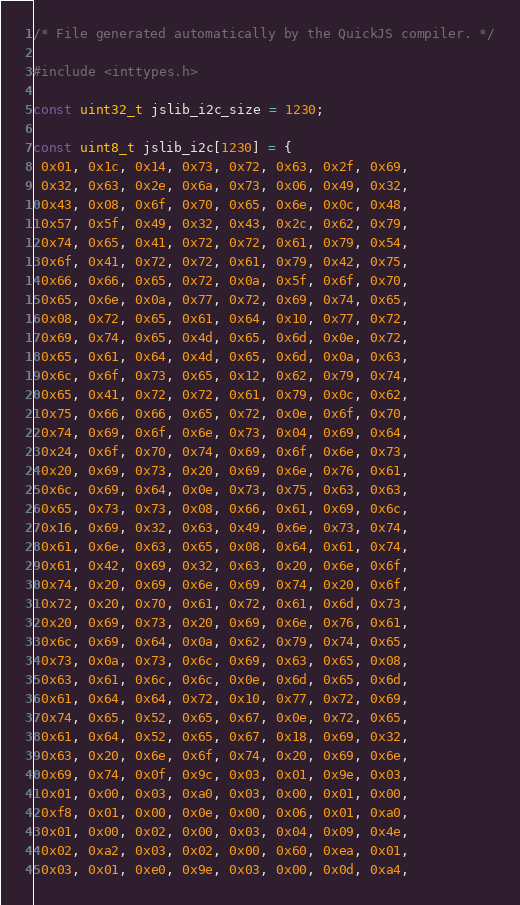<code> <loc_0><loc_0><loc_500><loc_500><_C_>/* File generated automatically by the QuickJS compiler. */

#include <inttypes.h>

const uint32_t jslib_i2c_size = 1230;

const uint8_t jslib_i2c[1230] = {
 0x01, 0x1c, 0x14, 0x73, 0x72, 0x63, 0x2f, 0x69,
 0x32, 0x63, 0x2e, 0x6a, 0x73, 0x06, 0x49, 0x32,
 0x43, 0x08, 0x6f, 0x70, 0x65, 0x6e, 0x0c, 0x48,
 0x57, 0x5f, 0x49, 0x32, 0x43, 0x2c, 0x62, 0x79,
 0x74, 0x65, 0x41, 0x72, 0x72, 0x61, 0x79, 0x54,
 0x6f, 0x41, 0x72, 0x72, 0x61, 0x79, 0x42, 0x75,
 0x66, 0x66, 0x65, 0x72, 0x0a, 0x5f, 0x6f, 0x70,
 0x65, 0x6e, 0x0a, 0x77, 0x72, 0x69, 0x74, 0x65,
 0x08, 0x72, 0x65, 0x61, 0x64, 0x10, 0x77, 0x72,
 0x69, 0x74, 0x65, 0x4d, 0x65, 0x6d, 0x0e, 0x72,
 0x65, 0x61, 0x64, 0x4d, 0x65, 0x6d, 0x0a, 0x63,
 0x6c, 0x6f, 0x73, 0x65, 0x12, 0x62, 0x79, 0x74,
 0x65, 0x41, 0x72, 0x72, 0x61, 0x79, 0x0c, 0x62,
 0x75, 0x66, 0x66, 0x65, 0x72, 0x0e, 0x6f, 0x70,
 0x74, 0x69, 0x6f, 0x6e, 0x73, 0x04, 0x69, 0x64,
 0x24, 0x6f, 0x70, 0x74, 0x69, 0x6f, 0x6e, 0x73,
 0x20, 0x69, 0x73, 0x20, 0x69, 0x6e, 0x76, 0x61,
 0x6c, 0x69, 0x64, 0x0e, 0x73, 0x75, 0x63, 0x63,
 0x65, 0x73, 0x73, 0x08, 0x66, 0x61, 0x69, 0x6c,
 0x16, 0x69, 0x32, 0x63, 0x49, 0x6e, 0x73, 0x74,
 0x61, 0x6e, 0x63, 0x65, 0x08, 0x64, 0x61, 0x74,
 0x61, 0x42, 0x69, 0x32, 0x63, 0x20, 0x6e, 0x6f,
 0x74, 0x20, 0x69, 0x6e, 0x69, 0x74, 0x20, 0x6f,
 0x72, 0x20, 0x70, 0x61, 0x72, 0x61, 0x6d, 0x73,
 0x20, 0x69, 0x73, 0x20, 0x69, 0x6e, 0x76, 0x61,
 0x6c, 0x69, 0x64, 0x0a, 0x62, 0x79, 0x74, 0x65,
 0x73, 0x0a, 0x73, 0x6c, 0x69, 0x63, 0x65, 0x08,
 0x63, 0x61, 0x6c, 0x6c, 0x0e, 0x6d, 0x65, 0x6d,
 0x61, 0x64, 0x64, 0x72, 0x10, 0x77, 0x72, 0x69,
 0x74, 0x65, 0x52, 0x65, 0x67, 0x0e, 0x72, 0x65,
 0x61, 0x64, 0x52, 0x65, 0x67, 0x18, 0x69, 0x32,
 0x63, 0x20, 0x6e, 0x6f, 0x74, 0x20, 0x69, 0x6e,
 0x69, 0x74, 0x0f, 0x9c, 0x03, 0x01, 0x9e, 0x03,
 0x01, 0x00, 0x03, 0xa0, 0x03, 0x00, 0x01, 0x00,
 0xf8, 0x01, 0x00, 0x0e, 0x00, 0x06, 0x01, 0xa0,
 0x01, 0x00, 0x02, 0x00, 0x03, 0x04, 0x09, 0x4e,
 0x02, 0xa2, 0x03, 0x02, 0x00, 0x60, 0xea, 0x01,
 0x03, 0x01, 0xe0, 0x9e, 0x03, 0x00, 0x0d, 0xa4,</code> 